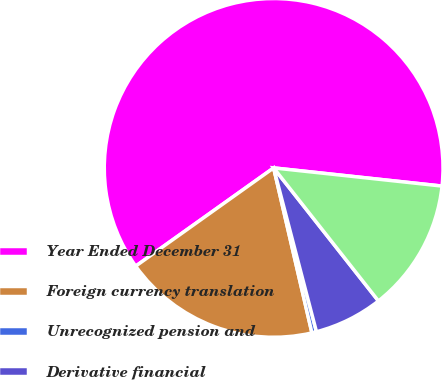Convert chart. <chart><loc_0><loc_0><loc_500><loc_500><pie_chart><fcel>Year Ended December 31<fcel>Foreign currency translation<fcel>Unrecognized pension and<fcel>Derivative financial<fcel>Total other comprehensive<nl><fcel>61.56%<fcel>18.78%<fcel>0.44%<fcel>6.55%<fcel>12.67%<nl></chart> 